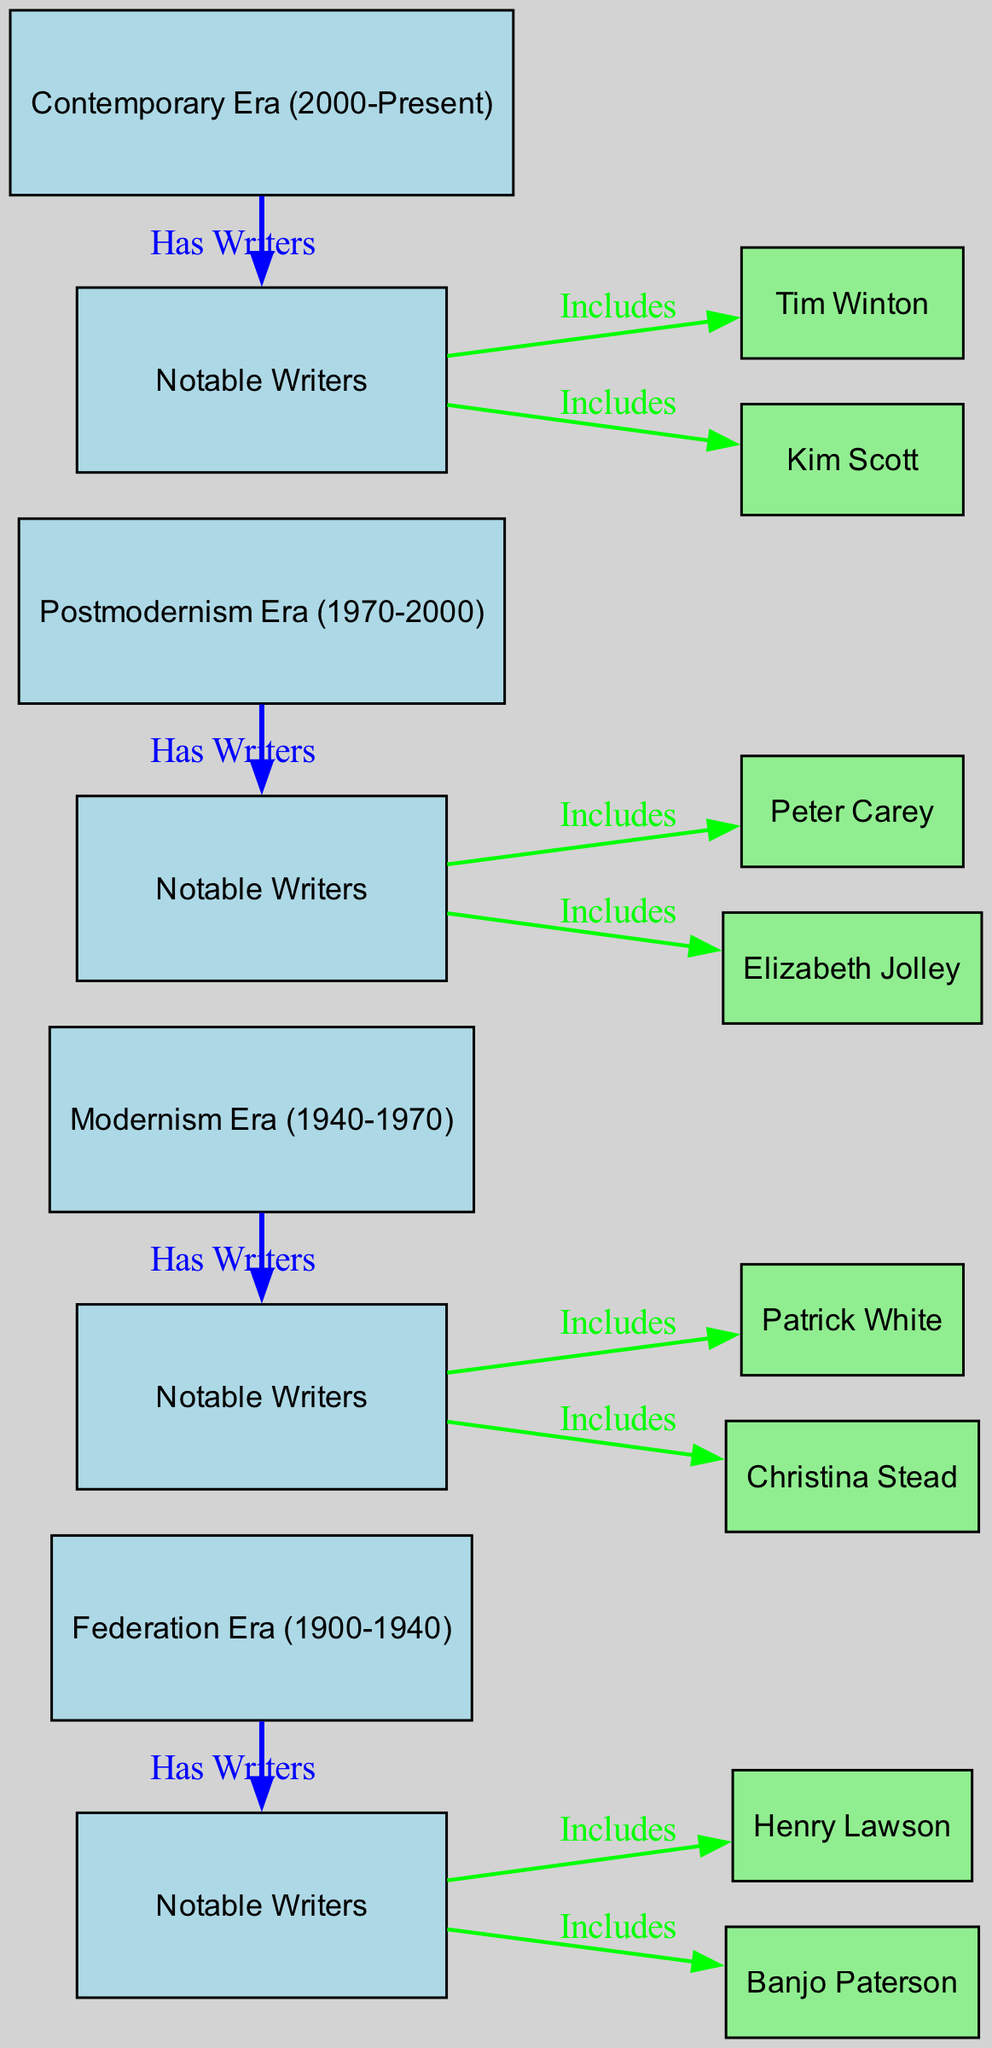What is the first era depicted in the diagram? The diagram lists the first era as "Federation Era (1900-1940)", which is the initial node connected in the sequence of historical literary eras.
Answer: Federation Era (1900-1940) How many notable writers are associated with the Postmodernism Era? The diagram shows a total of two notable writers, Peter Carey and Elizabeth Jolley, who are linked as nodes under the Postmodernism Era.
Answer: 2 Which era has Patrick White as a notable writer? By examining the nodes, it is apparent that Patrick White is associated with the "Modernism Era (1940-1970)", indicated as a notable writer connected to that era.
Answer: Modernism Era (1940-1970) What is the relationship between the Federation Era and its notable writers? The Federation Era directly has a relationship labeled "Has Writers" to a node that includes its notable writers Henry Lawson and Banjo Paterson, demonstrating that they are from this era.
Answer: Has Writers Which era follows the Modernism Era? The structure of the diagram indicates that the "Postmodernism Era (1970-2000)" directly follows the Modernism Era, representing a chronological progression in the evolution of Australian literature.
Answer: Postmodernism Era (1970-2000) What color represents the era nodes in the diagram? The diagram stipulates that the era nodes are represented in light blue, which can be confirmed by observing the fill color assigned to each era node.
Answer: Light blue Which two writers are highlighted in the Contemporary Era? The Contemporary Era showcases Tim Winton and Kim Scott as its notable writers, clearly labeled in the diagram under the corresponding era node.
Answer: Tim Winton, Kim Scott What distinguishes the diagram type used here as a social science diagram? The diagram specifically categorizes information about the evolution of literature by historical eras and notable writers, showing relationships and classifications unique to social sciences.
Answer: Classification of eras and writers 